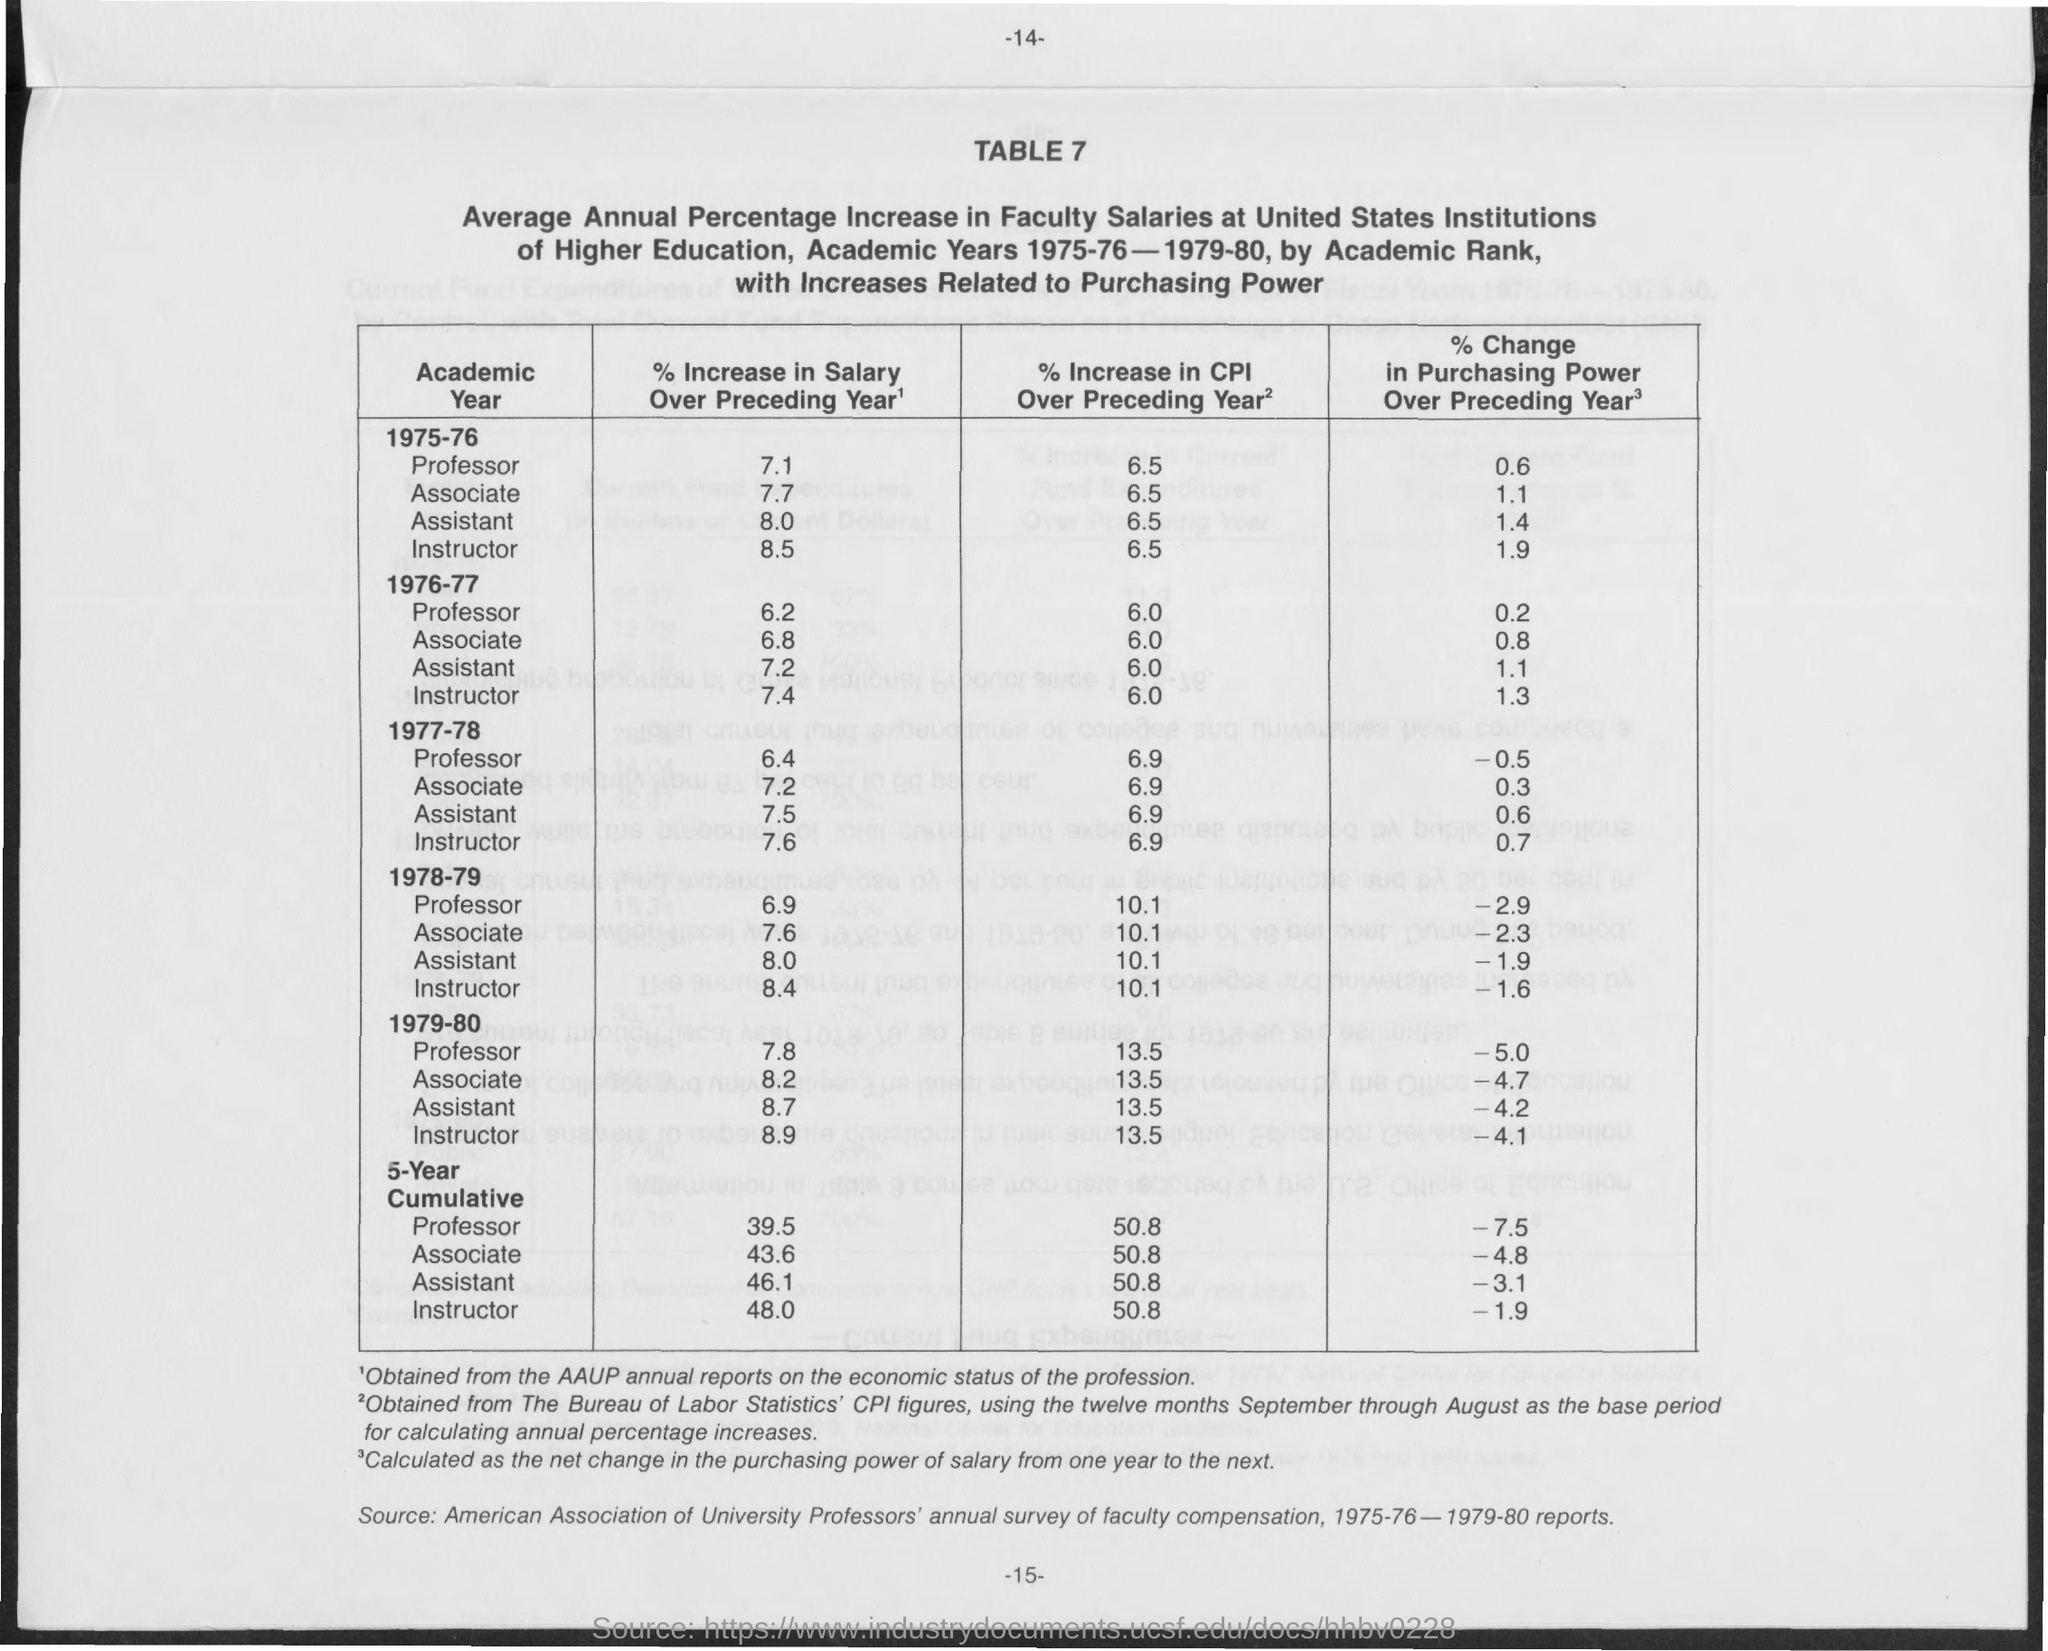Point out several critical features in this image. The page number seen at the top is -14-. The salary increase for a professor in the year 1975-76 was 7.1%. The assistant's salary in the year 1975-76 had a % increase over the preceding year of 8.0%. 